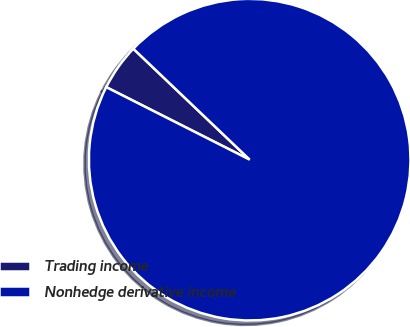<chart> <loc_0><loc_0><loc_500><loc_500><pie_chart><fcel>Trading income<fcel>Nonhedge derivative income<nl><fcel>4.67%<fcel>95.33%<nl></chart> 